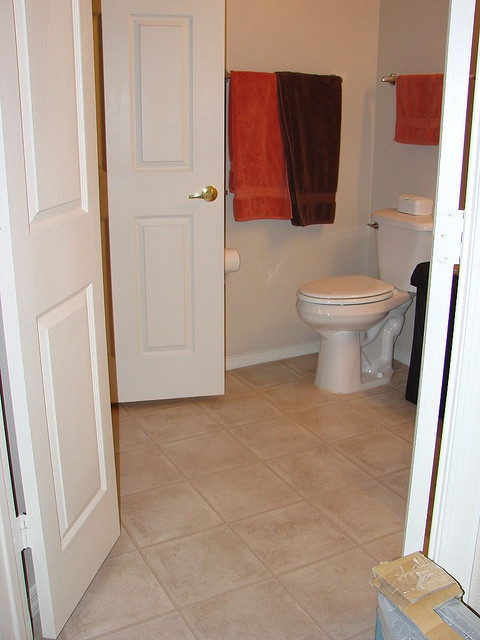Describe the objects in this image and their specific colors. I can see a toilet in darkgray and gray tones in this image. 